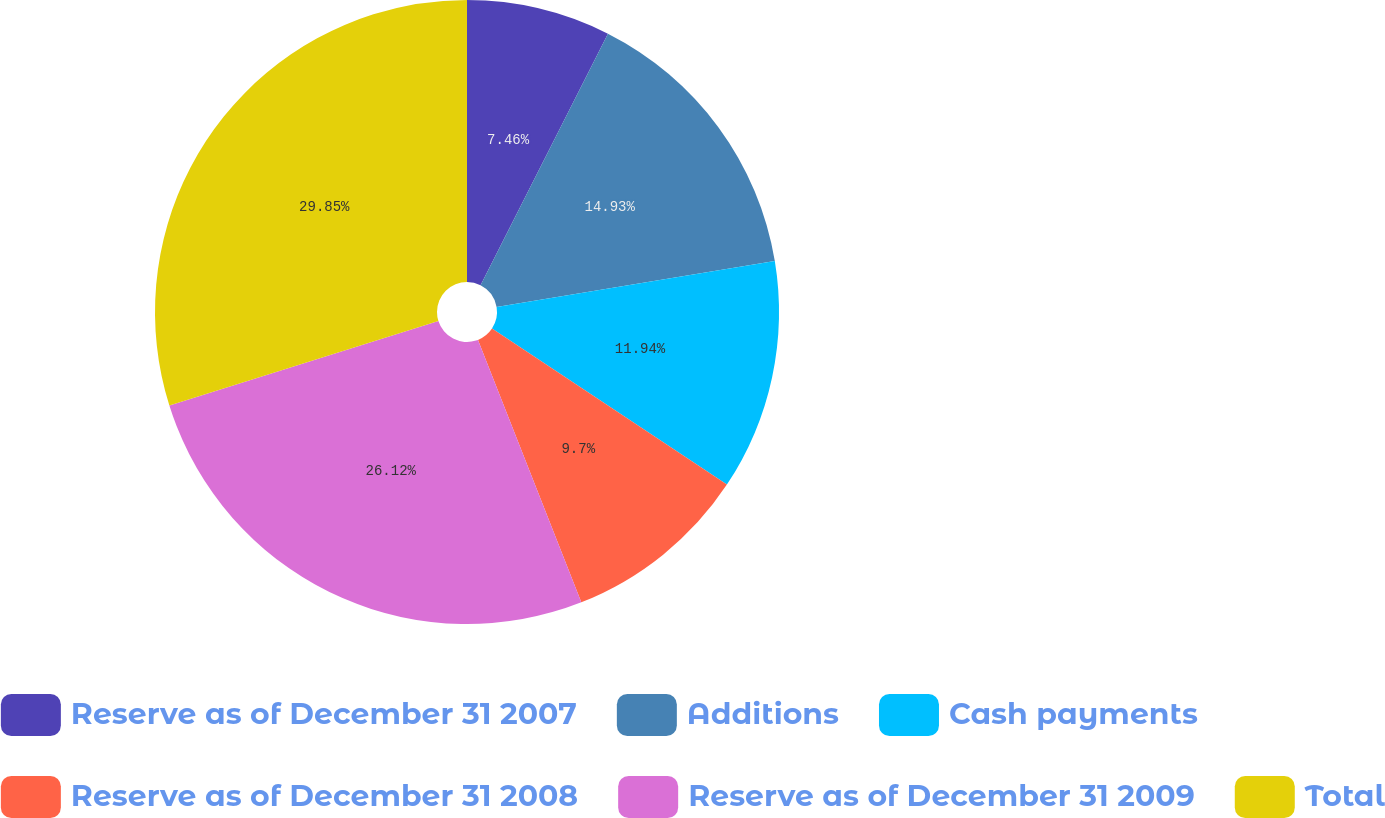<chart> <loc_0><loc_0><loc_500><loc_500><pie_chart><fcel>Reserve as of December 31 2007<fcel>Additions<fcel>Cash payments<fcel>Reserve as of December 31 2008<fcel>Reserve as of December 31 2009<fcel>Total<nl><fcel>7.46%<fcel>14.93%<fcel>11.94%<fcel>9.7%<fcel>26.12%<fcel>29.85%<nl></chart> 